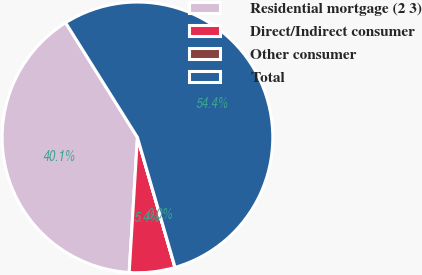Convert chart. <chart><loc_0><loc_0><loc_500><loc_500><pie_chart><fcel>Residential mortgage (2 3)<fcel>Direct/Indirect consumer<fcel>Other consumer<fcel>Total<nl><fcel>40.12%<fcel>5.45%<fcel>0.01%<fcel>54.42%<nl></chart> 